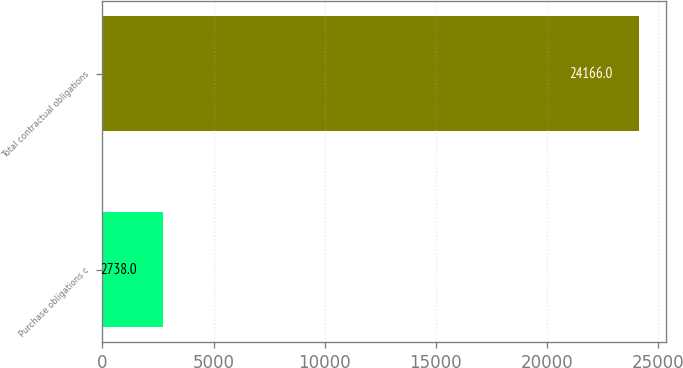Convert chart to OTSL. <chart><loc_0><loc_0><loc_500><loc_500><bar_chart><fcel>Purchase obligations c<fcel>Total contractual obligations<nl><fcel>2738<fcel>24166<nl></chart> 